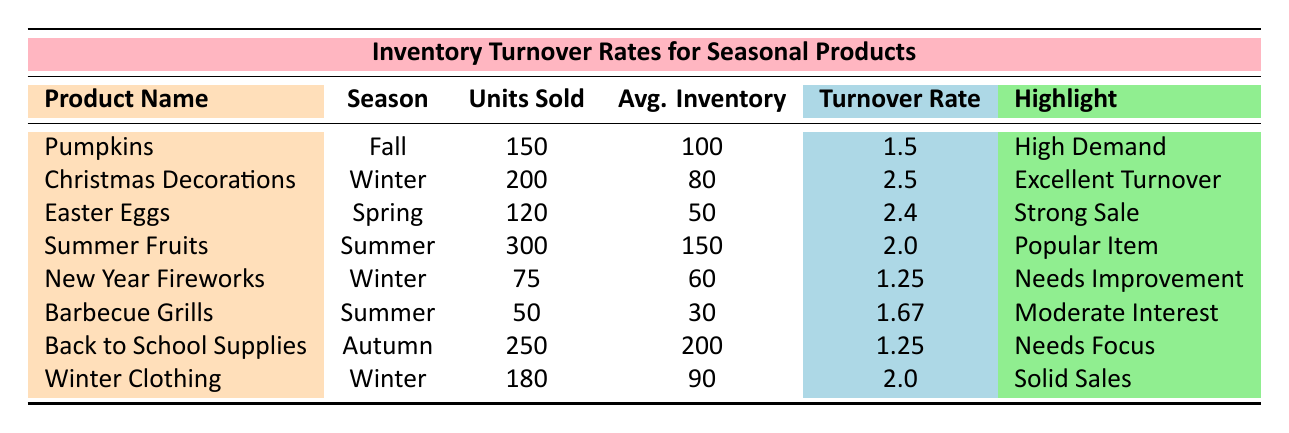What is the inventory turnover rate for Christmas Decorations? The table shows that the inventory turnover rate for Christmas Decorations is listed under the relevant column, which indicates a value of 2.5.
Answer: 2.5 Which seasonal product had the highest units sold? From the units sold column, Summer Fruits has the highest number with 300 units sold.
Answer: Summer Fruits Is the inventory turnover rate for Easter Eggs higher than that for Back to School Supplies? The turnover rate for Easter Eggs is 2.4 while the rate for Back to School Supplies is 1.25. Since 2.4 is greater than 1.25, the statement is true.
Answer: Yes How many units were sold in total for all products during the Winter season? The units sold for Winter products are Christmas Decorations (200) + New Year Fireworks (75) + Winter Clothing (180), which totals to 200 + 75 + 180 = 455.
Answer: 455 Which product has a "Needs Improvement" highlight and what is its turnover rate? The product that has a "Needs Improvement" highlight is New Year Fireworks, and its turnover rate is 1.25.
Answer: New Year Fireworks, 1.25 What is the average inventory turnover rate for all the products listed? The turnover rates are 1.5 (Pumpkins), 2.5 (Christmas Decorations), 2.4 (Easter Eggs), 2.0 (Summer Fruits), 1.25 (New Year Fireworks), 1.67 (Barbecue Grills), 1.25 (Back to School Supplies), and 2.0 (Winter Clothing). The sum is 1.5 + 2.5 + 2.4 + 2.0 + 1.25 + 1.67 + 1.25 + 2.0 = 14.57, and since there are 8 products, the average is 14.57 / 8 = 1.82.
Answer: 1.82 Which two products have the highest overall turnover rates, and what are their values? The highest turnover rates are for Christmas Decorations (2.5) and Easter Eggs (2.4). Both values can be found in the inventory turnover rate column.
Answer: Christmas Decorations (2.5), Easter Eggs (2.4) Are there more seasonal products with "High Demand" than those with "Needs Focus"? There is 1 product with "High Demand" (Pumpkins) and 1 product with "Needs Focus" (Back to School Supplies), indicating an equal count.
Answer: No (they are equal) 